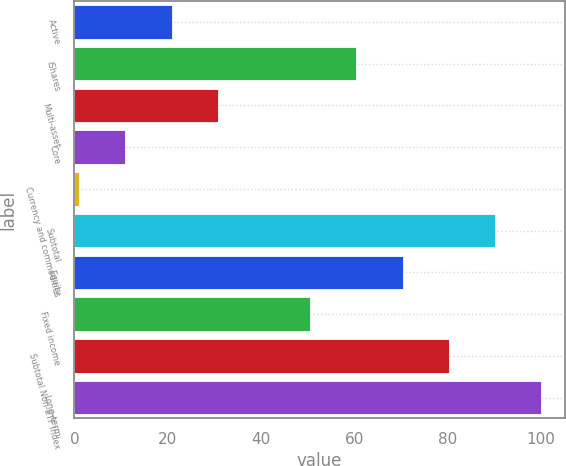Convert chart to OTSL. <chart><loc_0><loc_0><loc_500><loc_500><bar_chart><fcel>Active<fcel>iShares<fcel>Multi-asset<fcel>Core<fcel>Currency and commodities<fcel>Subtotal<fcel>Equity<fcel>Fixed income<fcel>Subtotal Non-ETF Index<fcel>Long-term<nl><fcel>20.8<fcel>60.4<fcel>30.7<fcel>10.9<fcel>1<fcel>90.1<fcel>70.3<fcel>50.5<fcel>80.2<fcel>100<nl></chart> 